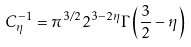Convert formula to latex. <formula><loc_0><loc_0><loc_500><loc_500>C _ { \eta } ^ { - 1 } = \pi ^ { 3 / 2 } 2 ^ { 3 - 2 \eta } \Gamma \left ( \frac { 3 } { 2 } - \eta \right )</formula> 